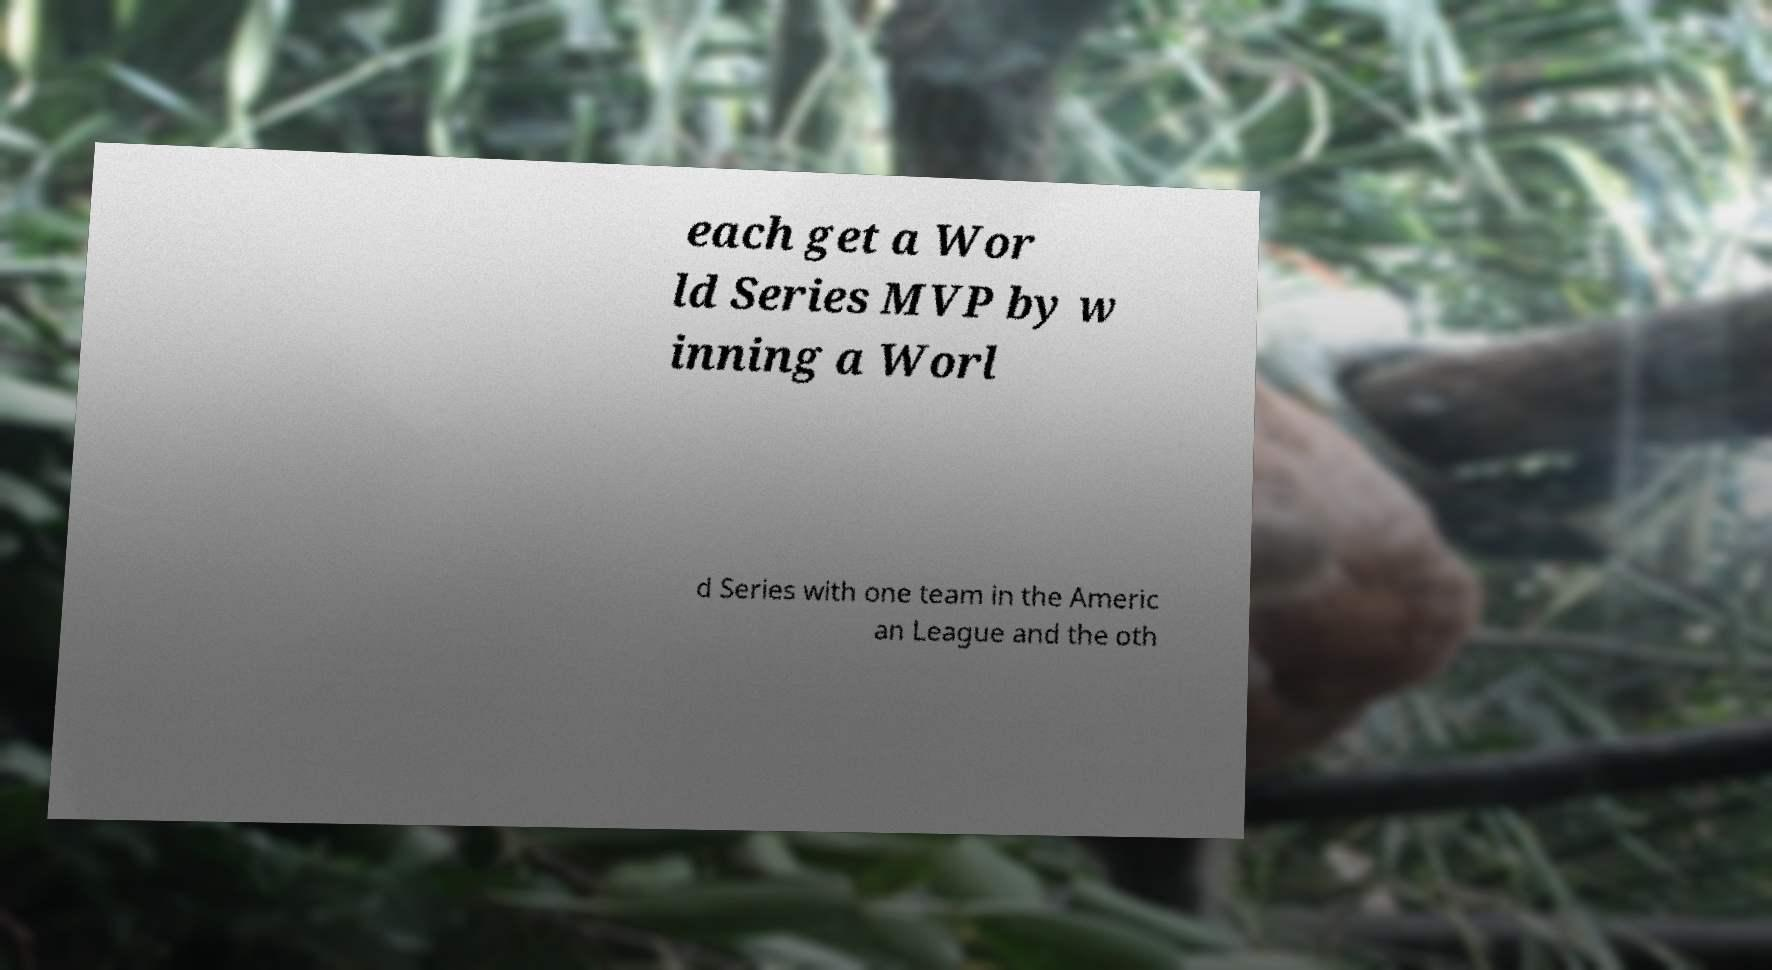What messages or text are displayed in this image? I need them in a readable, typed format. each get a Wor ld Series MVP by w inning a Worl d Series with one team in the Americ an League and the oth 